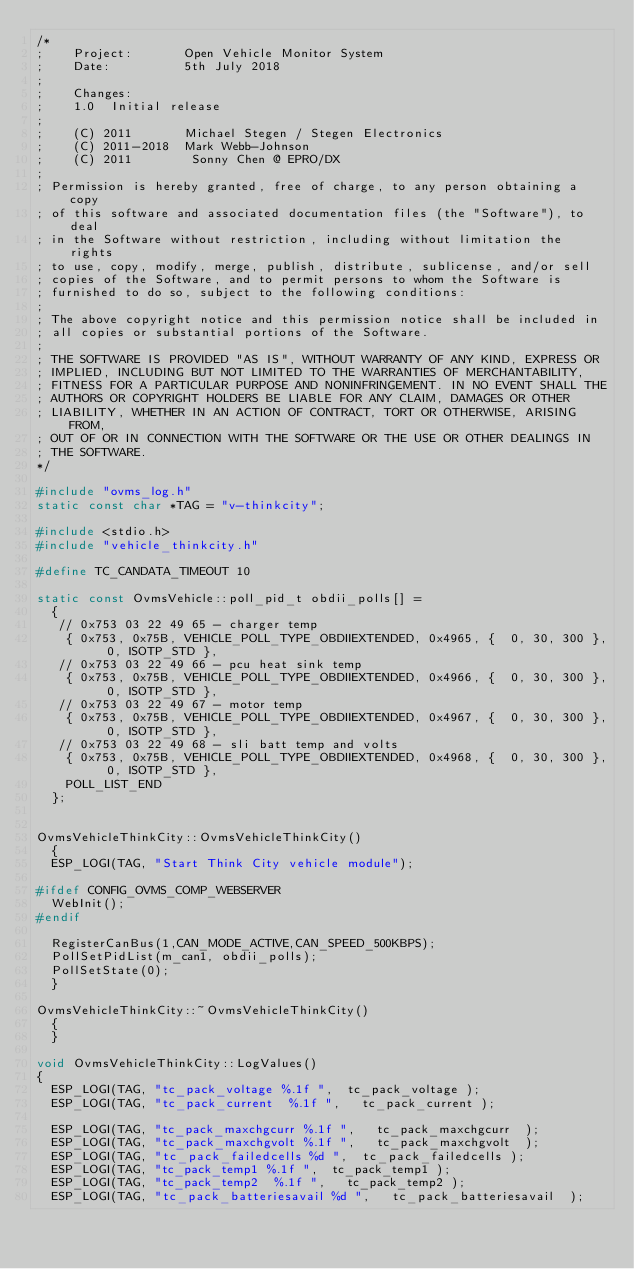Convert code to text. <code><loc_0><loc_0><loc_500><loc_500><_C++_>/*
;    Project:       Open Vehicle Monitor System
;    Date:          5th July 2018
;
;    Changes:
;    1.0  Initial release
;
;    (C) 2011       Michael Stegen / Stegen Electronics
;    (C) 2011-2018  Mark Webb-Johnson
;    (C) 2011        Sonny Chen @ EPRO/DX
;
; Permission is hereby granted, free of charge, to any person obtaining a copy
; of this software and associated documentation files (the "Software"), to deal
; in the Software without restriction, including without limitation the rights
; to use, copy, modify, merge, publish, distribute, sublicense, and/or sell
; copies of the Software, and to permit persons to whom the Software is
; furnished to do so, subject to the following conditions:
;
; The above copyright notice and this permission notice shall be included in
; all copies or substantial portions of the Software.
;
; THE SOFTWARE IS PROVIDED "AS IS", WITHOUT WARRANTY OF ANY KIND, EXPRESS OR
; IMPLIED, INCLUDING BUT NOT LIMITED TO THE WARRANTIES OF MERCHANTABILITY,
; FITNESS FOR A PARTICULAR PURPOSE AND NONINFRINGEMENT. IN NO EVENT SHALL THE
; AUTHORS OR COPYRIGHT HOLDERS BE LIABLE FOR ANY CLAIM, DAMAGES OR OTHER
; LIABILITY, WHETHER IN AN ACTION OF CONTRACT, TORT OR OTHERWISE, ARISING FROM,
; OUT OF OR IN CONNECTION WITH THE SOFTWARE OR THE USE OR OTHER DEALINGS IN
; THE SOFTWARE.
*/

#include "ovms_log.h"
static const char *TAG = "v-thinkcity";

#include <stdio.h>
#include "vehicle_thinkcity.h"

#define TC_CANDATA_TIMEOUT 10

static const OvmsVehicle::poll_pid_t obdii_polls[] =
  {
   // 0x753 03 22 49 65 - charger temp
    { 0x753, 0x75B, VEHICLE_POLL_TYPE_OBDIIEXTENDED, 0x4965, {  0, 30, 300 }, 0, ISOTP_STD }, 
   // 0x753 03 22 49 66 - pcu heat sink temp
    { 0x753, 0x75B, VEHICLE_POLL_TYPE_OBDIIEXTENDED, 0x4966, {  0, 30, 300 }, 0, ISOTP_STD }, 
   // 0x753 03 22 49 67 - motor temp
    { 0x753, 0x75B, VEHICLE_POLL_TYPE_OBDIIEXTENDED, 0x4967, {  0, 30, 300 }, 0, ISOTP_STD }, 
   // 0x753 03 22 49 68 - sli batt temp and volts
    { 0x753, 0x75B, VEHICLE_POLL_TYPE_OBDIIEXTENDED, 0x4968, {  0, 30, 300 }, 0, ISOTP_STD }, 
    POLL_LIST_END
  };


OvmsVehicleThinkCity::OvmsVehicleThinkCity()
  {
  ESP_LOGI(TAG, "Start Think City vehicle module");

#ifdef CONFIG_OVMS_COMP_WEBSERVER
  WebInit();
#endif

  RegisterCanBus(1,CAN_MODE_ACTIVE,CAN_SPEED_500KBPS);
  PollSetPidList(m_can1, obdii_polls);
  PollSetState(0);
  }

OvmsVehicleThinkCity::~OvmsVehicleThinkCity()
  {
  }

void OvmsVehicleThinkCity::LogValues()
{
  ESP_LOGI(TAG, "tc_pack_voltage %.1f ", 	tc_pack_voltage	);
  ESP_LOGI(TAG, "tc_pack_current	%.1f ", 	tc_pack_current	);
  
  ESP_LOGI(TAG, "tc_pack_maxchgcurr %.1f ", 	tc_pack_maxchgcurr	);
  ESP_LOGI(TAG, "tc_pack_maxchgvolt %.1f ", 	tc_pack_maxchgvolt	);
  ESP_LOGI(TAG, "tc_pack_failedcells %d ", 	tc_pack_failedcells	);
  ESP_LOGI(TAG, "tc_pack_temp1 %.1f ", 	tc_pack_temp1	);
  ESP_LOGI(TAG, "tc_pack_temp2	%.1f ", 	tc_pack_temp2	);
  ESP_LOGI(TAG, "tc_pack_batteriesavail	%d ", 	tc_pack_batteriesavail	);</code> 